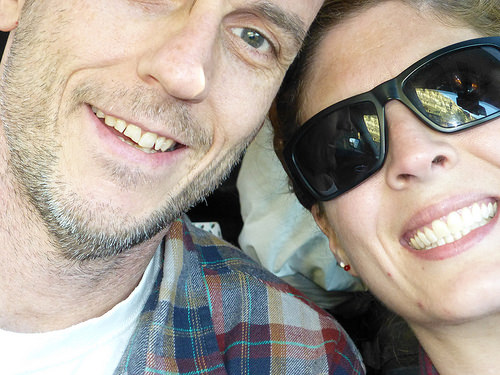<image>
Can you confirm if the girl is to the left of the man? Yes. From this viewpoint, the girl is positioned to the left side relative to the man. 